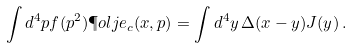Convert formula to latex. <formula><loc_0><loc_0><loc_500><loc_500>\int d ^ { 4 } p f ( p ^ { 2 } ) \P o l j e _ { c } ( x , p ) = \int d ^ { 4 } y \, \Delta ( x - y ) J ( y ) \, .</formula> 